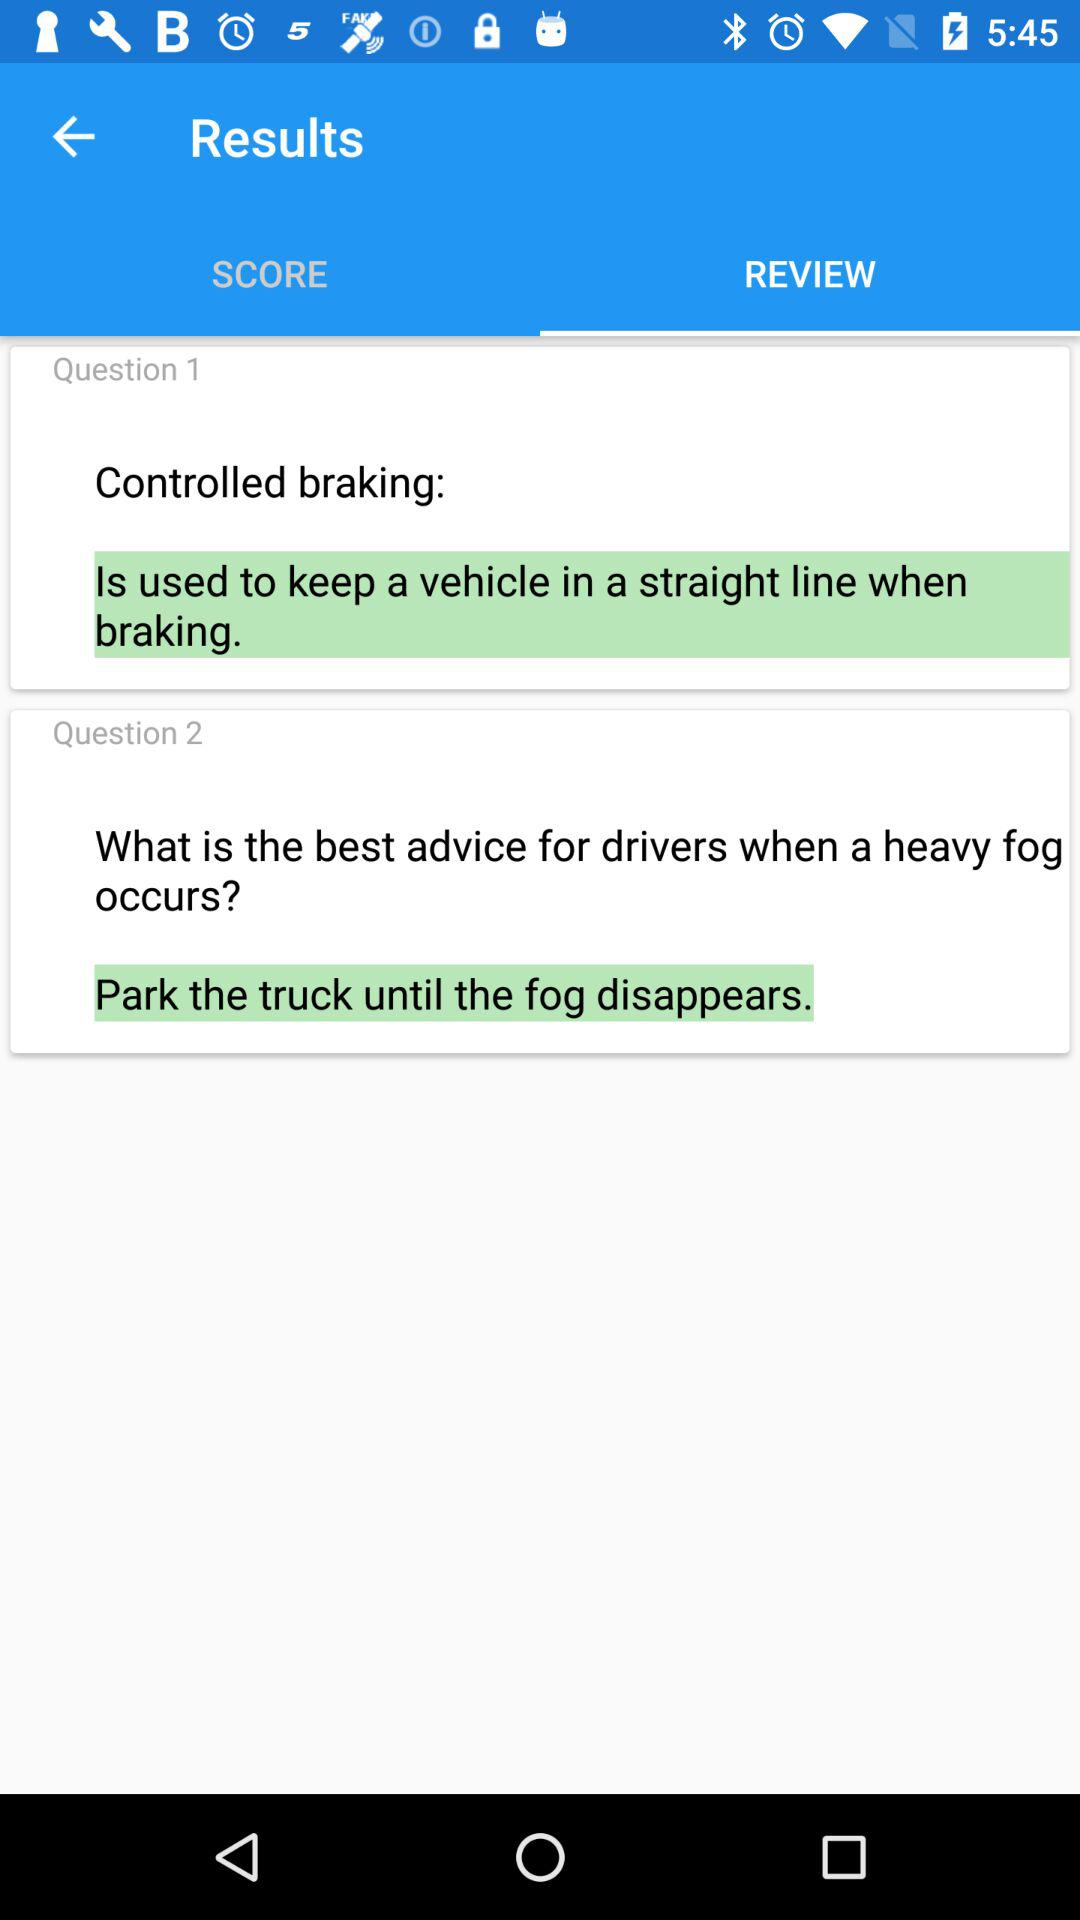What is controlled braking? The controlled braking is used to keep a vehicle in a straight line when braking. 